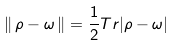Convert formula to latex. <formula><loc_0><loc_0><loc_500><loc_500>\| \, \rho - \omega \, \| = \frac { 1 } { 2 } T r | \rho - \omega |</formula> 